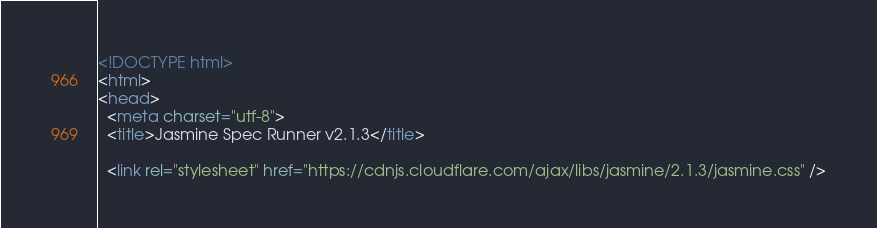<code> <loc_0><loc_0><loc_500><loc_500><_HTML_><!DOCTYPE html>
<html>
<head>
  <meta charset="utf-8">
  <title>Jasmine Spec Runner v2.1.3</title>

  <link rel="stylesheet" href="https://cdnjs.cloudflare.com/ajax/libs/jasmine/2.1.3/jasmine.css" />
</code> 